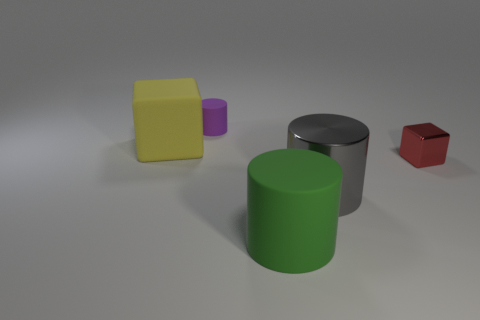Add 5 large gray metal things. How many objects exist? 10 Subtract all blocks. How many objects are left? 3 Subtract all tiny purple shiny cylinders. Subtract all large gray metallic cylinders. How many objects are left? 4 Add 4 purple rubber cylinders. How many purple rubber cylinders are left? 5 Add 3 small brown shiny objects. How many small brown shiny objects exist? 3 Subtract 0 brown cylinders. How many objects are left? 5 